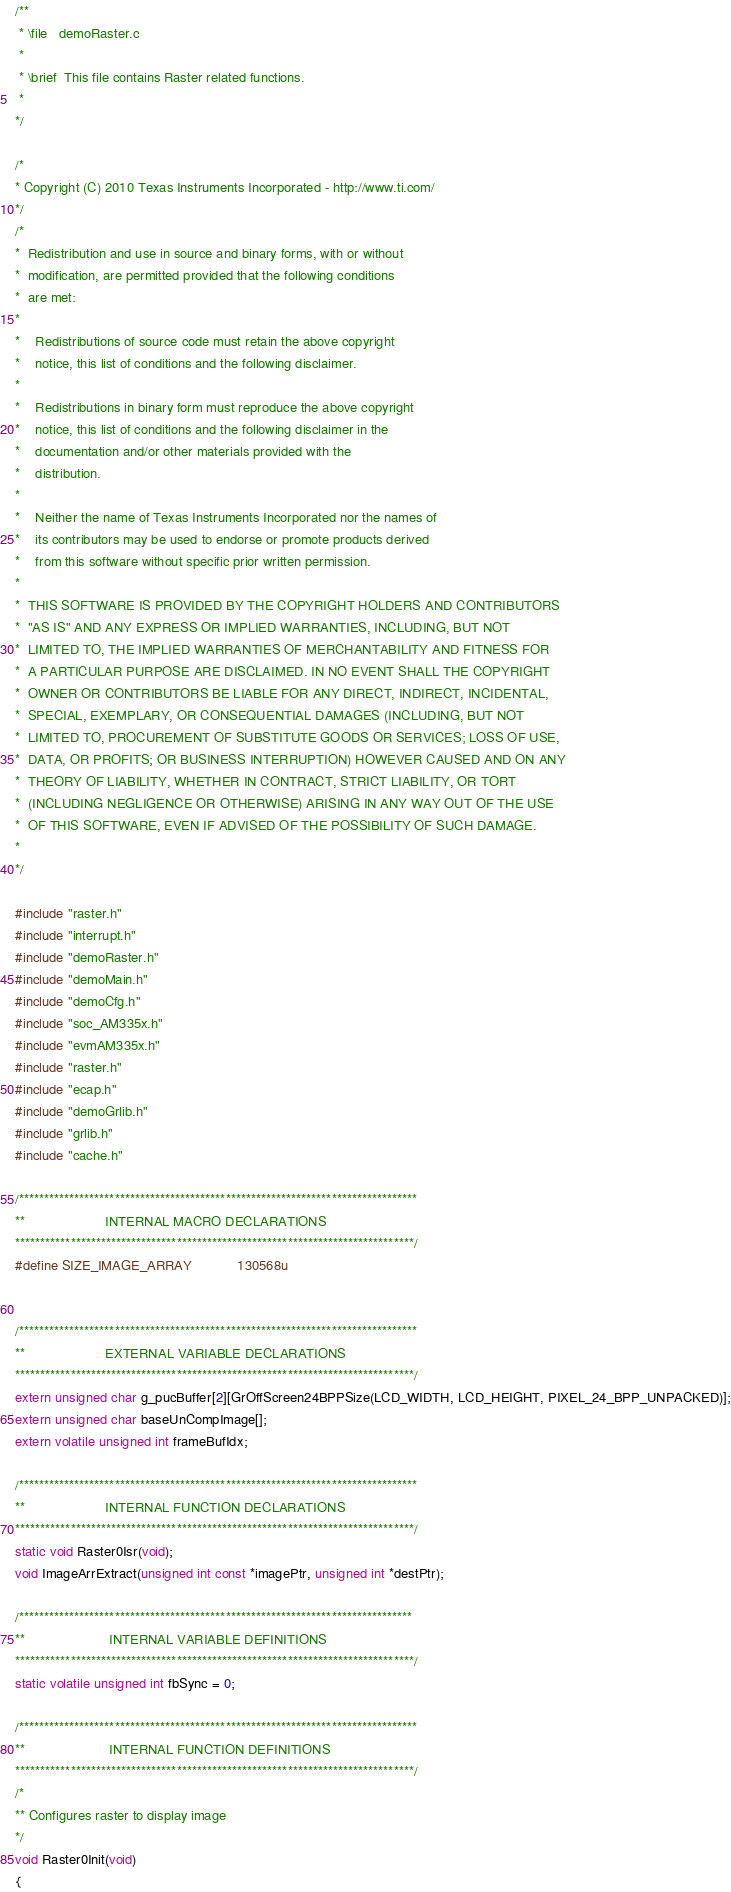<code> <loc_0><loc_0><loc_500><loc_500><_C_>/**
 * \file   demoRaster.c
 *
 * \brief  This file contains Raster related functions.
 *
*/

/*
* Copyright (C) 2010 Texas Instruments Incorporated - http://www.ti.com/
*/
/*
*  Redistribution and use in source and binary forms, with or without
*  modification, are permitted provided that the following conditions
*  are met:
*
*    Redistributions of source code must retain the above copyright
*    notice, this list of conditions and the following disclaimer.
*
*    Redistributions in binary form must reproduce the above copyright
*    notice, this list of conditions and the following disclaimer in the
*    documentation and/or other materials provided with the
*    distribution.
*
*    Neither the name of Texas Instruments Incorporated nor the names of
*    its contributors may be used to endorse or promote products derived
*    from this software without specific prior written permission.
*
*  THIS SOFTWARE IS PROVIDED BY THE COPYRIGHT HOLDERS AND CONTRIBUTORS
*  "AS IS" AND ANY EXPRESS OR IMPLIED WARRANTIES, INCLUDING, BUT NOT
*  LIMITED TO, THE IMPLIED WARRANTIES OF MERCHANTABILITY AND FITNESS FOR
*  A PARTICULAR PURPOSE ARE DISCLAIMED. IN NO EVENT SHALL THE COPYRIGHT
*  OWNER OR CONTRIBUTORS BE LIABLE FOR ANY DIRECT, INDIRECT, INCIDENTAL,
*  SPECIAL, EXEMPLARY, OR CONSEQUENTIAL DAMAGES (INCLUDING, BUT NOT
*  LIMITED TO, PROCUREMENT OF SUBSTITUTE GOODS OR SERVICES; LOSS OF USE,
*  DATA, OR PROFITS; OR BUSINESS INTERRUPTION) HOWEVER CAUSED AND ON ANY
*  THEORY OF LIABILITY, WHETHER IN CONTRACT, STRICT LIABILITY, OR TORT
*  (INCLUDING NEGLIGENCE OR OTHERWISE) ARISING IN ANY WAY OUT OF THE USE
*  OF THIS SOFTWARE, EVEN IF ADVISED OF THE POSSIBILITY OF SUCH DAMAGE.
*
*/

#include "raster.h"
#include "interrupt.h"
#include "demoRaster.h"
#include "demoMain.h"
#include "demoCfg.h"
#include "soc_AM335x.h"
#include "evmAM335x.h"
#include "raster.h"
#include "ecap.h"
#include "demoGrlib.h"
#include "grlib.h"
#include "cache.h"

/*******************************************************************************
**                     INTERNAL MACRO DECLARATIONS
*******************************************************************************/
#define SIZE_IMAGE_ARRAY            130568u


/*******************************************************************************
**                     EXTERNAL VARIABLE DECLARATIONS
*******************************************************************************/
extern unsigned char g_pucBuffer[2][GrOffScreen24BPPSize(LCD_WIDTH, LCD_HEIGHT, PIXEL_24_BPP_UNPACKED)];
extern unsigned char baseUnCompImage[];
extern volatile unsigned int frameBufIdx;

/*******************************************************************************
**                     INTERNAL FUNCTION DECLARATIONS
*******************************************************************************/
static void Raster0Isr(void);
void ImageArrExtract(unsigned int const *imagePtr, unsigned int *destPtr);

/******************************************************************************
**                      INTERNAL VARIABLE DEFINITIONS
*******************************************************************************/
static volatile unsigned int fbSync = 0;

/*******************************************************************************
**                      INTERNAL FUNCTION DEFINITIONS
*******************************************************************************/
/*
** Configures raster to display image
*/
void Raster0Init(void)
{</code> 